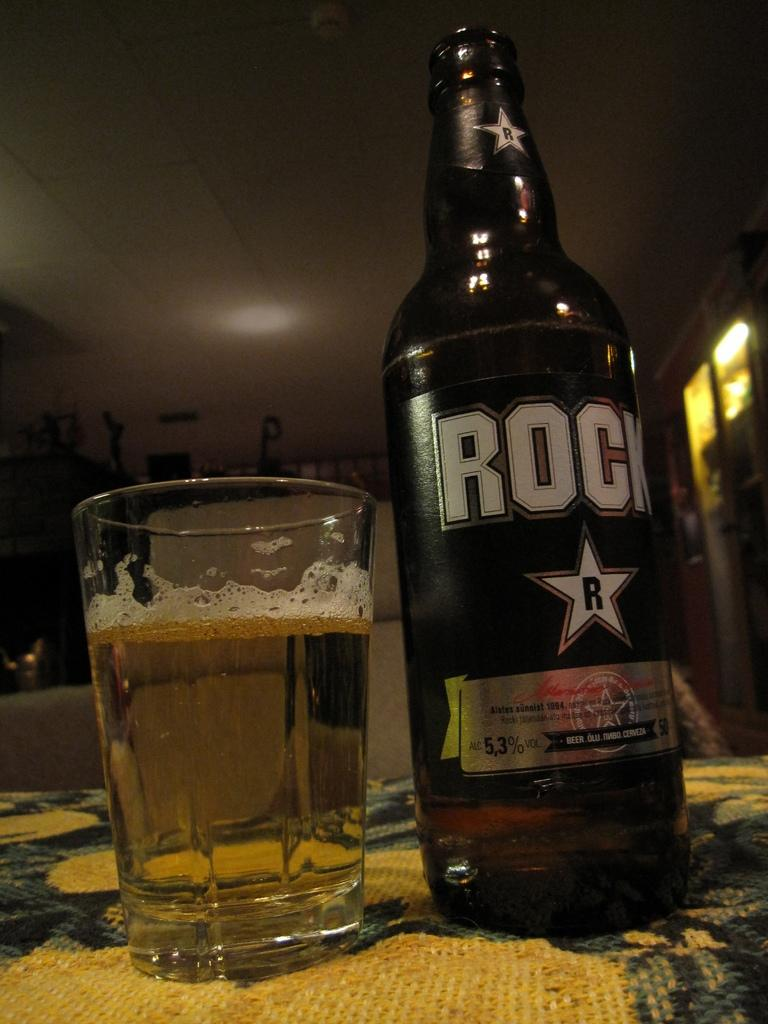Provide a one-sentence caption for the provided image. A glass of beer sits next to the bottle that says "Rock" on the label and is 5.3% alcohol. 